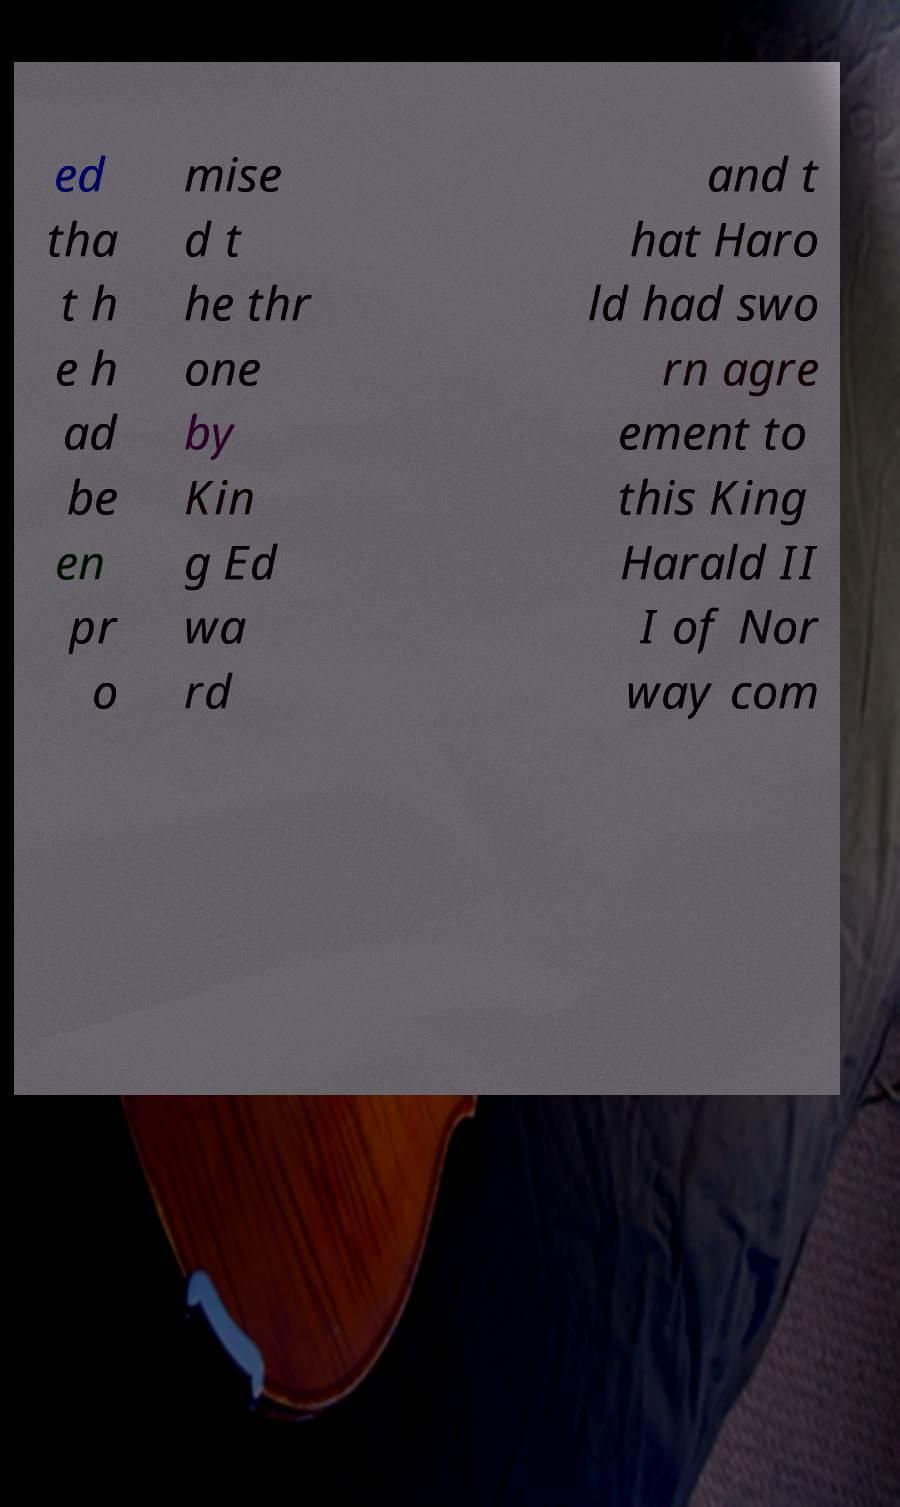There's text embedded in this image that I need extracted. Can you transcribe it verbatim? ed tha t h e h ad be en pr o mise d t he thr one by Kin g Ed wa rd and t hat Haro ld had swo rn agre ement to this King Harald II I of Nor way com 